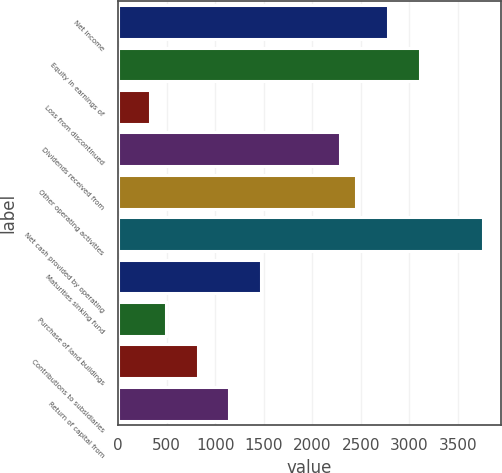Convert chart. <chart><loc_0><loc_0><loc_500><loc_500><bar_chart><fcel>Net income<fcel>Equity in earnings of<fcel>Loss from discontinued<fcel>Dividends received from<fcel>Other operating activities<fcel>Net cash provided by operating<fcel>Maturities sinking fund<fcel>Purchase of land buildings<fcel>Contributions to subsidiaries<fcel>Return of capital from<nl><fcel>2779.8<fcel>3106.6<fcel>328.8<fcel>2289.6<fcel>2453<fcel>3760.2<fcel>1472.6<fcel>492.2<fcel>819<fcel>1145.8<nl></chart> 